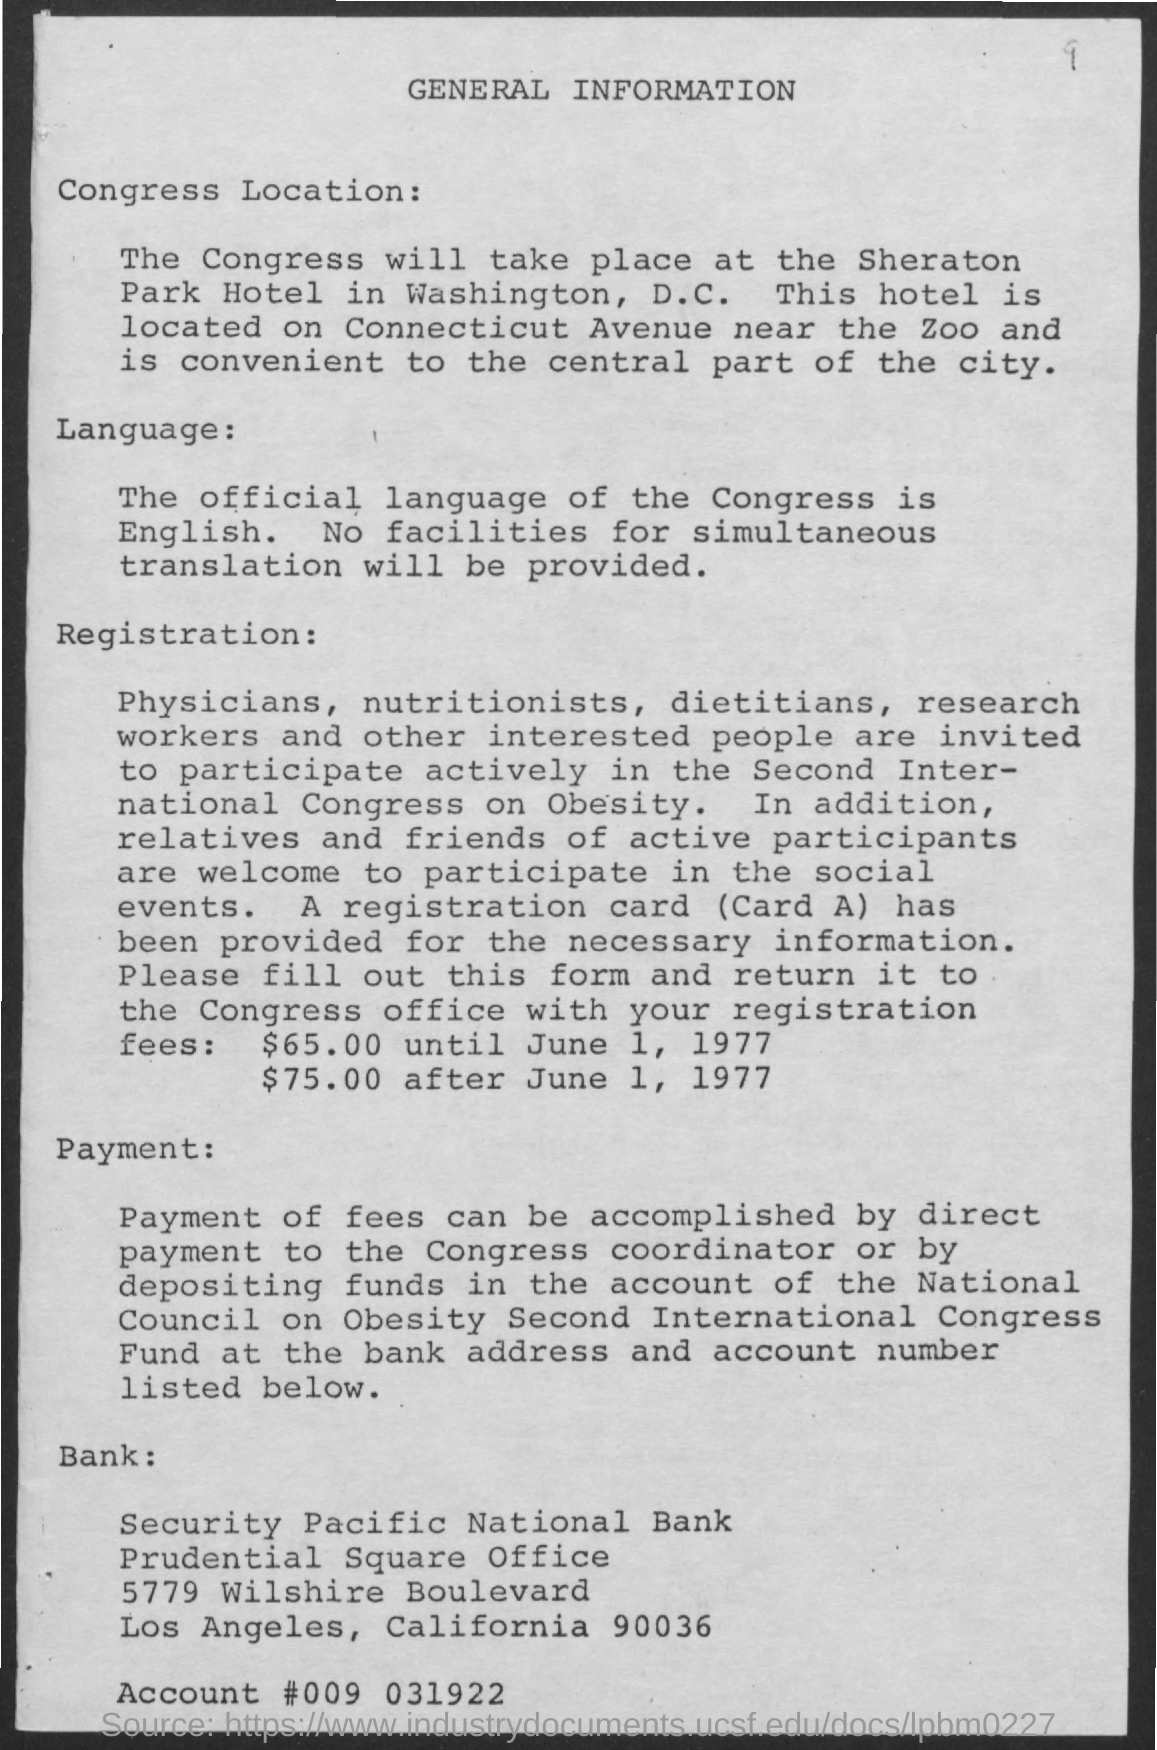Draw attention to some important aspects in this diagram. As of June 1, 1977, the registration fees were $75.00. The account number is 009 031922. The title of the document is General Information. The official language of Congress is English. As of June 1, 1977, the registration fees were $65.00. 